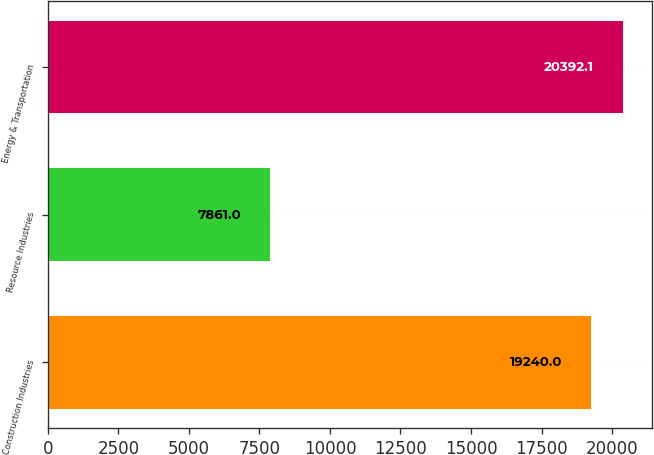Convert chart. <chart><loc_0><loc_0><loc_500><loc_500><bar_chart><fcel>Construction Industries<fcel>Resource Industries<fcel>Energy & Transportation<nl><fcel>19240<fcel>7861<fcel>20392.1<nl></chart> 